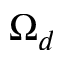<formula> <loc_0><loc_0><loc_500><loc_500>\Omega _ { d }</formula> 